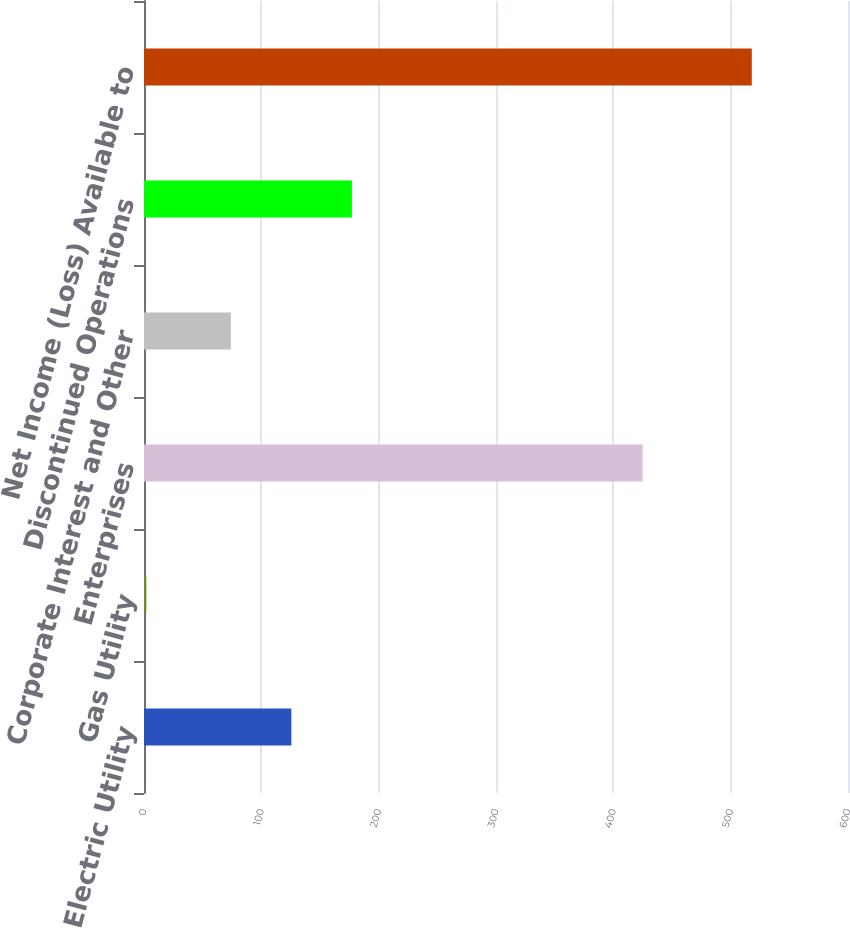Convert chart. <chart><loc_0><loc_0><loc_500><loc_500><bar_chart><fcel>Electric Utility<fcel>Gas Utility<fcel>Enterprises<fcel>Corporate Interest and Other<fcel>Discontinued Operations<fcel>Net Income (Loss) Available to<nl><fcel>125.6<fcel>2<fcel>425<fcel>74<fcel>177.2<fcel>518<nl></chart> 